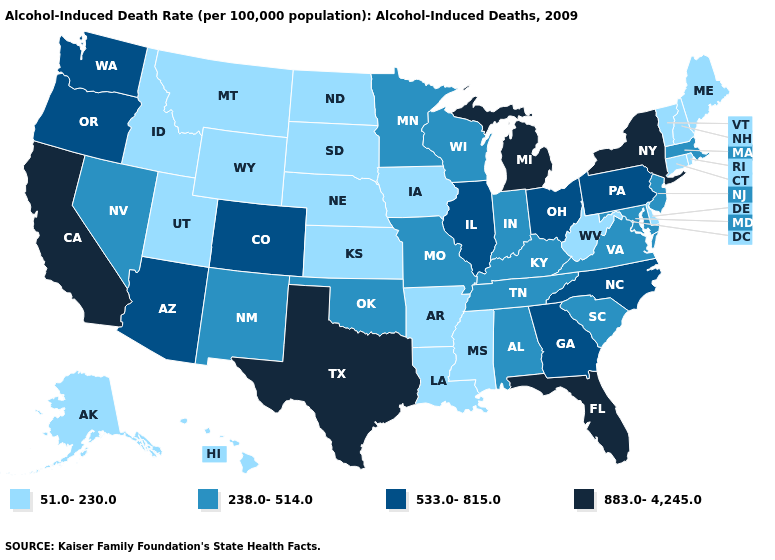What is the highest value in states that border Delaware?
Give a very brief answer. 533.0-815.0. Name the states that have a value in the range 883.0-4,245.0?
Give a very brief answer. California, Florida, Michigan, New York, Texas. Does Delaware have a lower value than Rhode Island?
Write a very short answer. No. Which states hav the highest value in the Northeast?
Be succinct. New York. Name the states that have a value in the range 883.0-4,245.0?
Keep it brief. California, Florida, Michigan, New York, Texas. Does Nebraska have the lowest value in the USA?
Keep it brief. Yes. Among the states that border Nevada , does California have the highest value?
Quick response, please. Yes. Which states have the lowest value in the USA?
Give a very brief answer. Alaska, Arkansas, Connecticut, Delaware, Hawaii, Idaho, Iowa, Kansas, Louisiana, Maine, Mississippi, Montana, Nebraska, New Hampshire, North Dakota, Rhode Island, South Dakota, Utah, Vermont, West Virginia, Wyoming. Name the states that have a value in the range 238.0-514.0?
Be succinct. Alabama, Indiana, Kentucky, Maryland, Massachusetts, Minnesota, Missouri, Nevada, New Jersey, New Mexico, Oklahoma, South Carolina, Tennessee, Virginia, Wisconsin. What is the value of Hawaii?
Keep it brief. 51.0-230.0. Among the states that border Illinois , which have the lowest value?
Give a very brief answer. Iowa. Name the states that have a value in the range 51.0-230.0?
Give a very brief answer. Alaska, Arkansas, Connecticut, Delaware, Hawaii, Idaho, Iowa, Kansas, Louisiana, Maine, Mississippi, Montana, Nebraska, New Hampshire, North Dakota, Rhode Island, South Dakota, Utah, Vermont, West Virginia, Wyoming. Does New Mexico have the same value as Arizona?
Quick response, please. No. Among the states that border Rhode Island , does Connecticut have the highest value?
Concise answer only. No. Among the states that border Tennessee , which have the highest value?
Give a very brief answer. Georgia, North Carolina. 